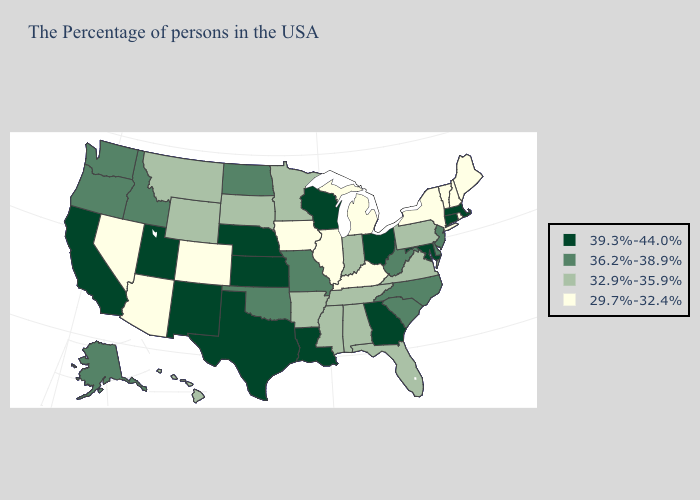How many symbols are there in the legend?
Answer briefly. 4. What is the value of Alabama?
Quick response, please. 32.9%-35.9%. Name the states that have a value in the range 32.9%-35.9%?
Concise answer only. Pennsylvania, Virginia, Florida, Indiana, Alabama, Tennessee, Mississippi, Arkansas, Minnesota, South Dakota, Wyoming, Montana, Hawaii. What is the lowest value in states that border Utah?
Quick response, please. 29.7%-32.4%. What is the lowest value in the MidWest?
Concise answer only. 29.7%-32.4%. Which states hav the highest value in the South?
Write a very short answer. Maryland, Georgia, Louisiana, Texas. What is the value of Nevada?
Answer briefly. 29.7%-32.4%. Does the map have missing data?
Give a very brief answer. No. Which states have the lowest value in the West?
Be succinct. Colorado, Arizona, Nevada. What is the lowest value in states that border Massachusetts?
Answer briefly. 29.7%-32.4%. Does Tennessee have the highest value in the South?
Quick response, please. No. Among the states that border Maine , which have the highest value?
Give a very brief answer. New Hampshire. Does the first symbol in the legend represent the smallest category?
Give a very brief answer. No. What is the lowest value in states that border Louisiana?
Answer briefly. 32.9%-35.9%. How many symbols are there in the legend?
Quick response, please. 4. 